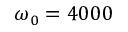<formula> <loc_0><loc_0><loc_500><loc_500>\omega _ { 0 } = 4 0 0 0</formula> 